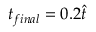Convert formula to latex. <formula><loc_0><loc_0><loc_500><loc_500>t _ { f i n a l } = 0 . 2 \hat { t }</formula> 